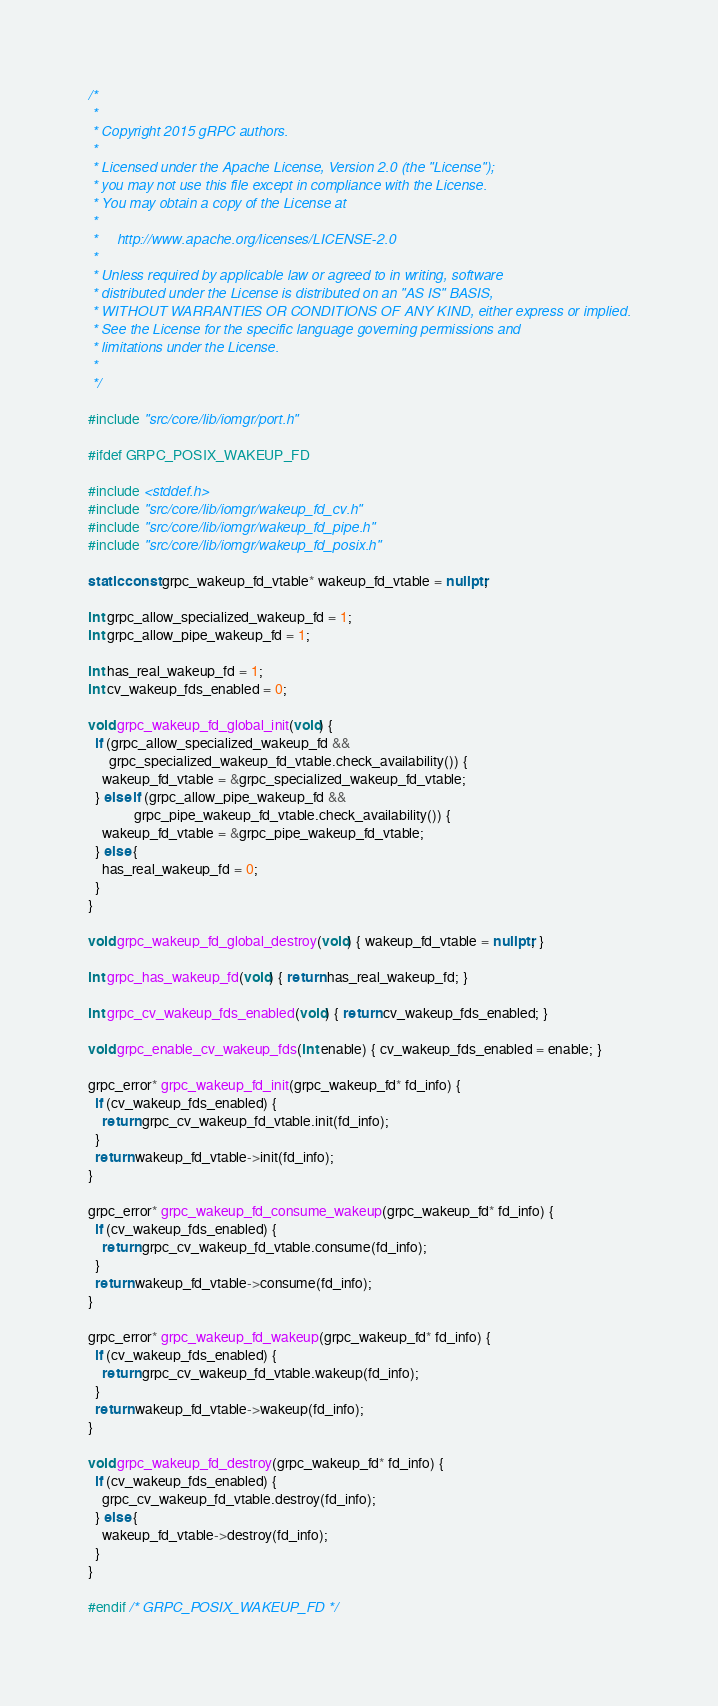Convert code to text. <code><loc_0><loc_0><loc_500><loc_500><_C++_>/*
 *
 * Copyright 2015 gRPC authors.
 *
 * Licensed under the Apache License, Version 2.0 (the "License");
 * you may not use this file except in compliance with the License.
 * You may obtain a copy of the License at
 *
 *     http://www.apache.org/licenses/LICENSE-2.0
 *
 * Unless required by applicable law or agreed to in writing, software
 * distributed under the License is distributed on an "AS IS" BASIS,
 * WITHOUT WARRANTIES OR CONDITIONS OF ANY KIND, either express or implied.
 * See the License for the specific language governing permissions and
 * limitations under the License.
 *
 */

#include "src/core/lib/iomgr/port.h"

#ifdef GRPC_POSIX_WAKEUP_FD

#include <stddef.h>
#include "src/core/lib/iomgr/wakeup_fd_cv.h"
#include "src/core/lib/iomgr/wakeup_fd_pipe.h"
#include "src/core/lib/iomgr/wakeup_fd_posix.h"

static const grpc_wakeup_fd_vtable* wakeup_fd_vtable = nullptr;

int grpc_allow_specialized_wakeup_fd = 1;
int grpc_allow_pipe_wakeup_fd = 1;

int has_real_wakeup_fd = 1;
int cv_wakeup_fds_enabled = 0;

void grpc_wakeup_fd_global_init(void) {
  if (grpc_allow_specialized_wakeup_fd &&
      grpc_specialized_wakeup_fd_vtable.check_availability()) {
    wakeup_fd_vtable = &grpc_specialized_wakeup_fd_vtable;
  } else if (grpc_allow_pipe_wakeup_fd &&
             grpc_pipe_wakeup_fd_vtable.check_availability()) {
    wakeup_fd_vtable = &grpc_pipe_wakeup_fd_vtable;
  } else {
    has_real_wakeup_fd = 0;
  }
}

void grpc_wakeup_fd_global_destroy(void) { wakeup_fd_vtable = nullptr; }

int grpc_has_wakeup_fd(void) { return has_real_wakeup_fd; }

int grpc_cv_wakeup_fds_enabled(void) { return cv_wakeup_fds_enabled; }

void grpc_enable_cv_wakeup_fds(int enable) { cv_wakeup_fds_enabled = enable; }

grpc_error* grpc_wakeup_fd_init(grpc_wakeup_fd* fd_info) {
  if (cv_wakeup_fds_enabled) {
    return grpc_cv_wakeup_fd_vtable.init(fd_info);
  }
  return wakeup_fd_vtable->init(fd_info);
}

grpc_error* grpc_wakeup_fd_consume_wakeup(grpc_wakeup_fd* fd_info) {
  if (cv_wakeup_fds_enabled) {
    return grpc_cv_wakeup_fd_vtable.consume(fd_info);
  }
  return wakeup_fd_vtable->consume(fd_info);
}

grpc_error* grpc_wakeup_fd_wakeup(grpc_wakeup_fd* fd_info) {
  if (cv_wakeup_fds_enabled) {
    return grpc_cv_wakeup_fd_vtable.wakeup(fd_info);
  }
  return wakeup_fd_vtable->wakeup(fd_info);
}

void grpc_wakeup_fd_destroy(grpc_wakeup_fd* fd_info) {
  if (cv_wakeup_fds_enabled) {
    grpc_cv_wakeup_fd_vtable.destroy(fd_info);
  } else {
    wakeup_fd_vtable->destroy(fd_info);
  }
}

#endif /* GRPC_POSIX_WAKEUP_FD */
</code> 